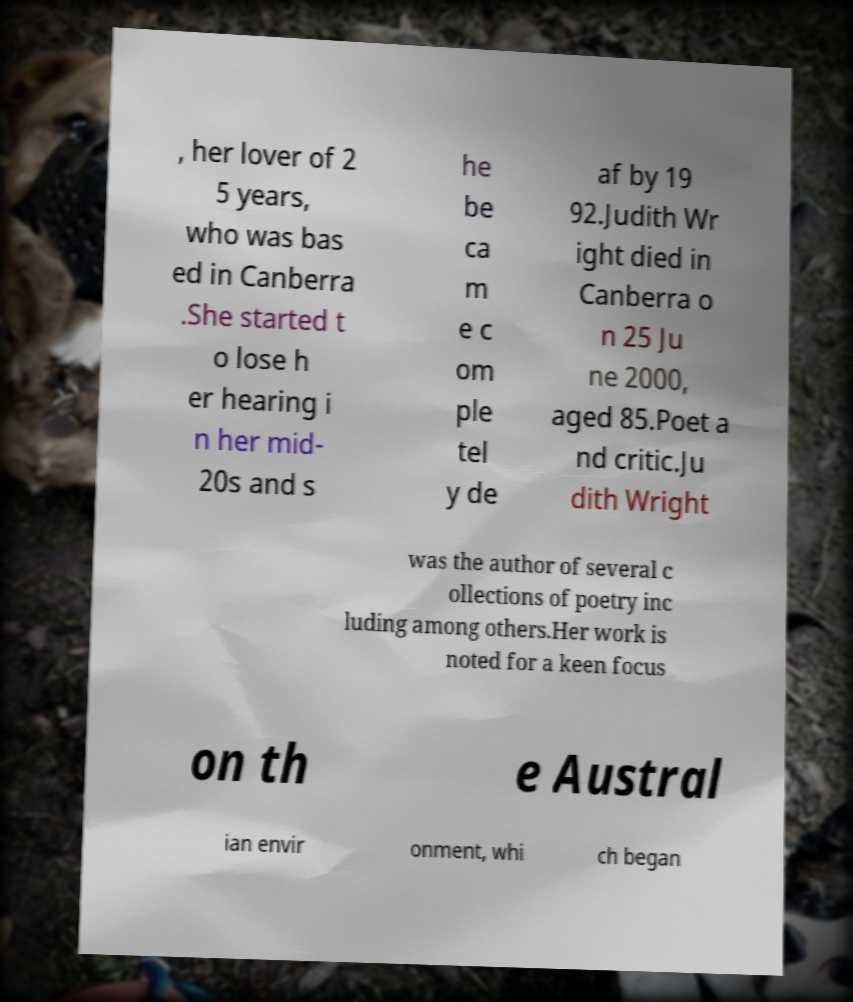What messages or text are displayed in this image? I need them in a readable, typed format. , her lover of 2 5 years, who was bas ed in Canberra .She started t o lose h er hearing i n her mid- 20s and s he be ca m e c om ple tel y de af by 19 92.Judith Wr ight died in Canberra o n 25 Ju ne 2000, aged 85.Poet a nd critic.Ju dith Wright was the author of several c ollections of poetry inc luding among others.Her work is noted for a keen focus on th e Austral ian envir onment, whi ch began 